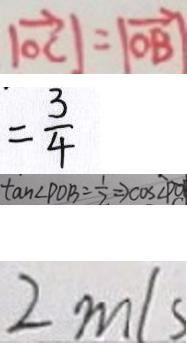Convert formula to latex. <formula><loc_0><loc_0><loc_500><loc_500>\vert \overrightarrow { O C } \vert = \vert \overrightarrow { O B } \vert 
 = \frac { 3 } { 4 } 
 \tan \angle P O B = \frac { 1 } { 2 } \Rightarrow \cos \angle P O 
 2 m / s</formula> 